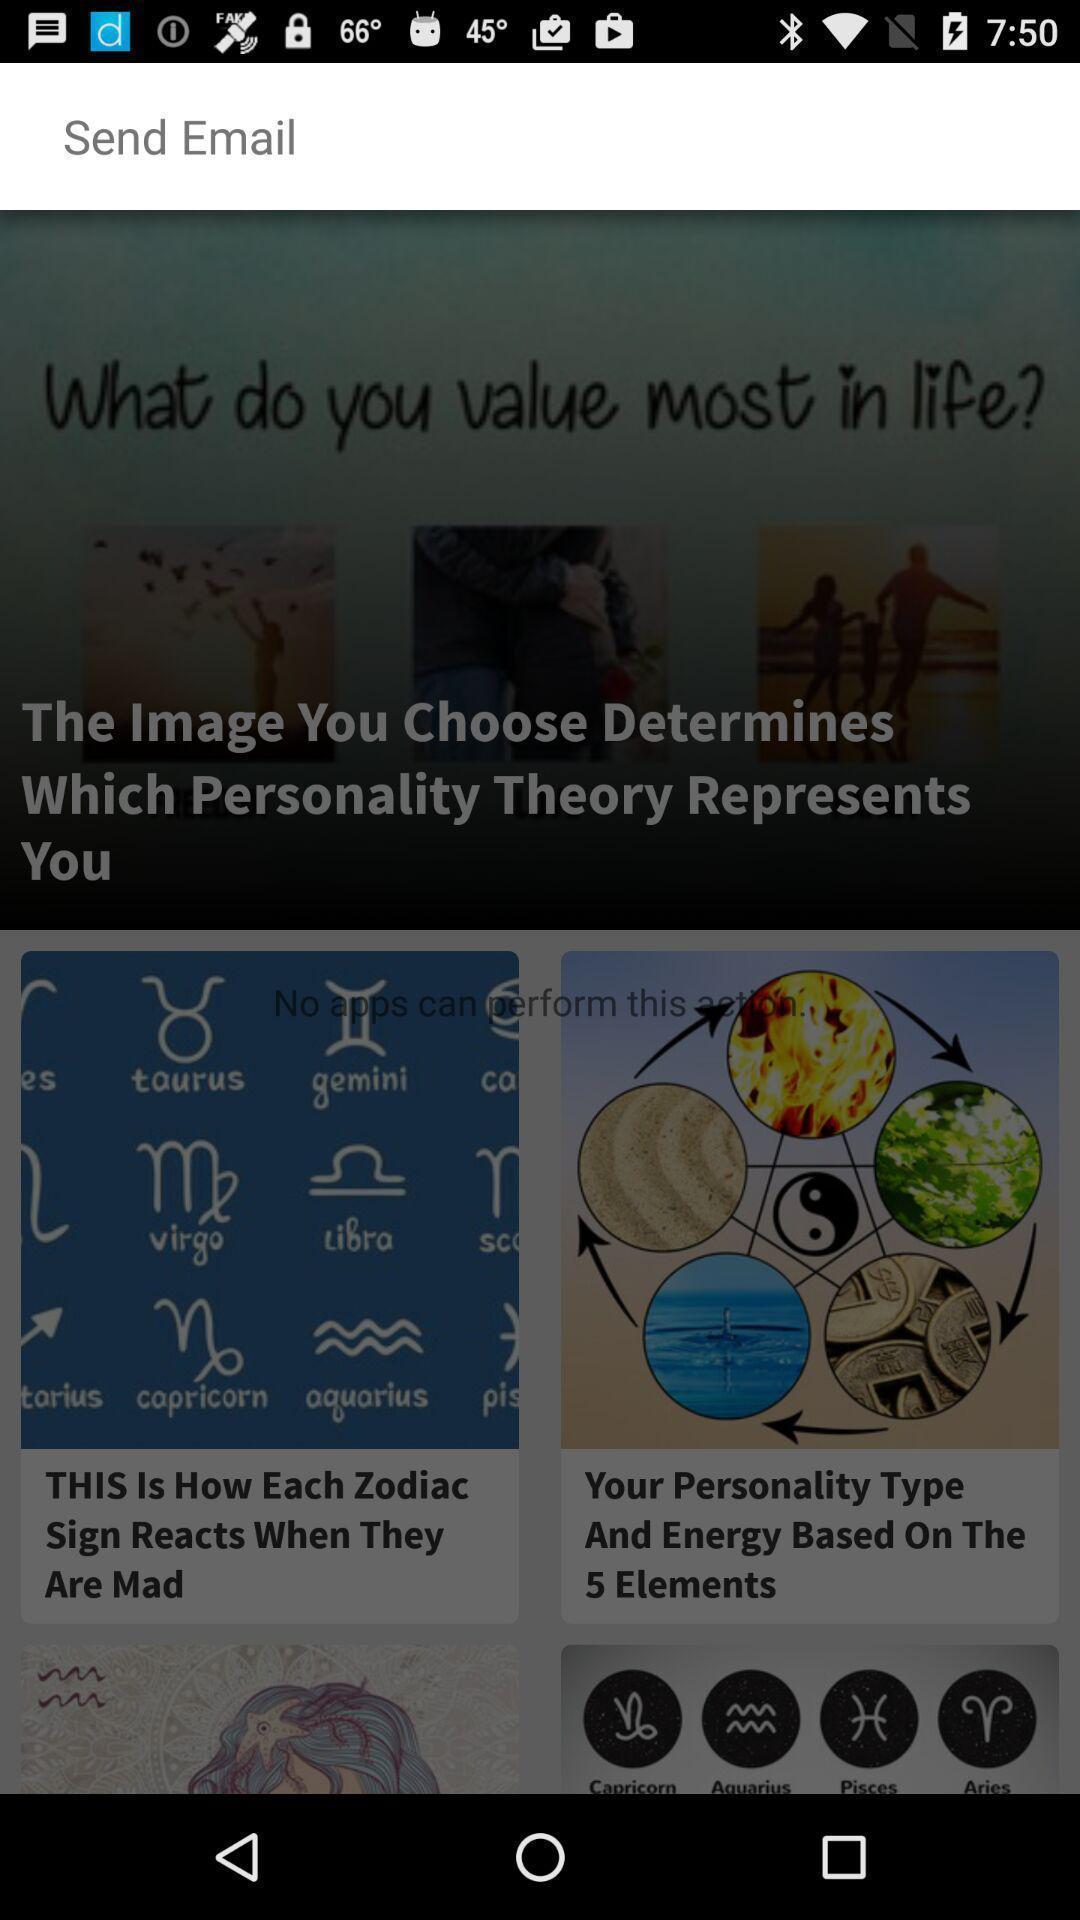What can you discern from this picture? Page is about a zodiac sign and its details. 